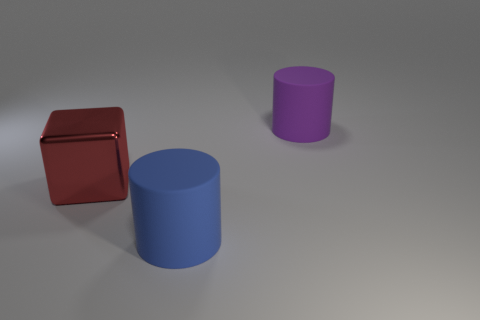Add 2 red metallic objects. How many objects exist? 5 Subtract all blocks. How many objects are left? 2 Add 3 cylinders. How many cylinders are left? 5 Add 3 red cubes. How many red cubes exist? 4 Subtract 0 blue blocks. How many objects are left? 3 Subtract all big blue rubber objects. Subtract all rubber cylinders. How many objects are left? 0 